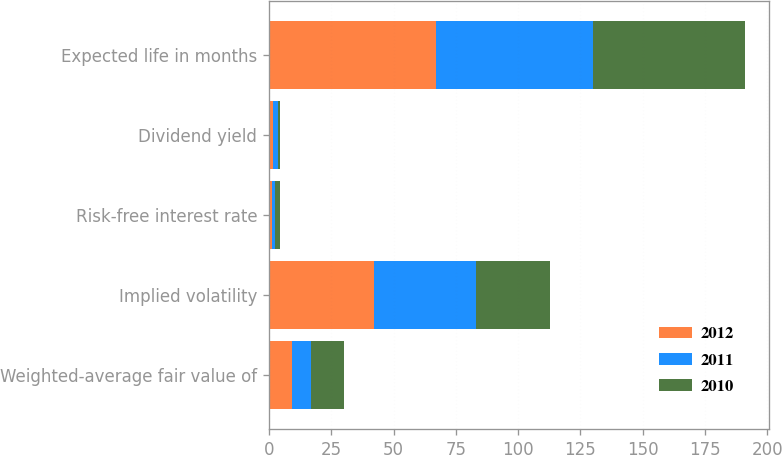Convert chart to OTSL. <chart><loc_0><loc_0><loc_500><loc_500><stacked_bar_chart><ecel><fcel>Weighted-average fair value of<fcel>Implied volatility<fcel>Risk-free interest rate<fcel>Dividend yield<fcel>Expected life in months<nl><fcel>2012<fcel>9.06<fcel>42<fcel>1.17<fcel>1.83<fcel>67<nl><fcel>2011<fcel>7.85<fcel>41<fcel>1.2<fcel>1.97<fcel>63<nl><fcel>2010<fcel>13.33<fcel>30<fcel>2.06<fcel>0.68<fcel>61<nl></chart> 